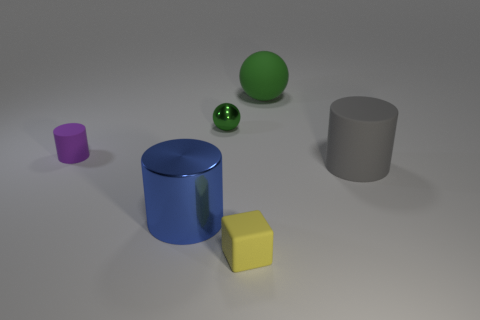Is the number of blue cylinders in front of the blue object the same as the number of small purple matte cylinders?
Give a very brief answer. No. Does the rubber block have the same size as the blue shiny cylinder?
Give a very brief answer. No. Are there any big gray objects behind the ball that is to the left of the big thing behind the big rubber cylinder?
Offer a terse response. No. What material is the large object that is the same shape as the small metallic thing?
Give a very brief answer. Rubber. There is a green sphere on the right side of the matte cube; what number of tiny green things are behind it?
Ensure brevity in your answer.  0. What size is the green object to the left of the thing in front of the cylinder in front of the big rubber cylinder?
Offer a terse response. Small. What color is the big matte object that is left of the object to the right of the big green sphere?
Give a very brief answer. Green. How many other objects are the same material as the gray cylinder?
Ensure brevity in your answer.  3. What number of other things are there of the same color as the tiny shiny sphere?
Ensure brevity in your answer.  1. The large thing that is behind the cylinder left of the large metallic object is made of what material?
Make the answer very short. Rubber. 